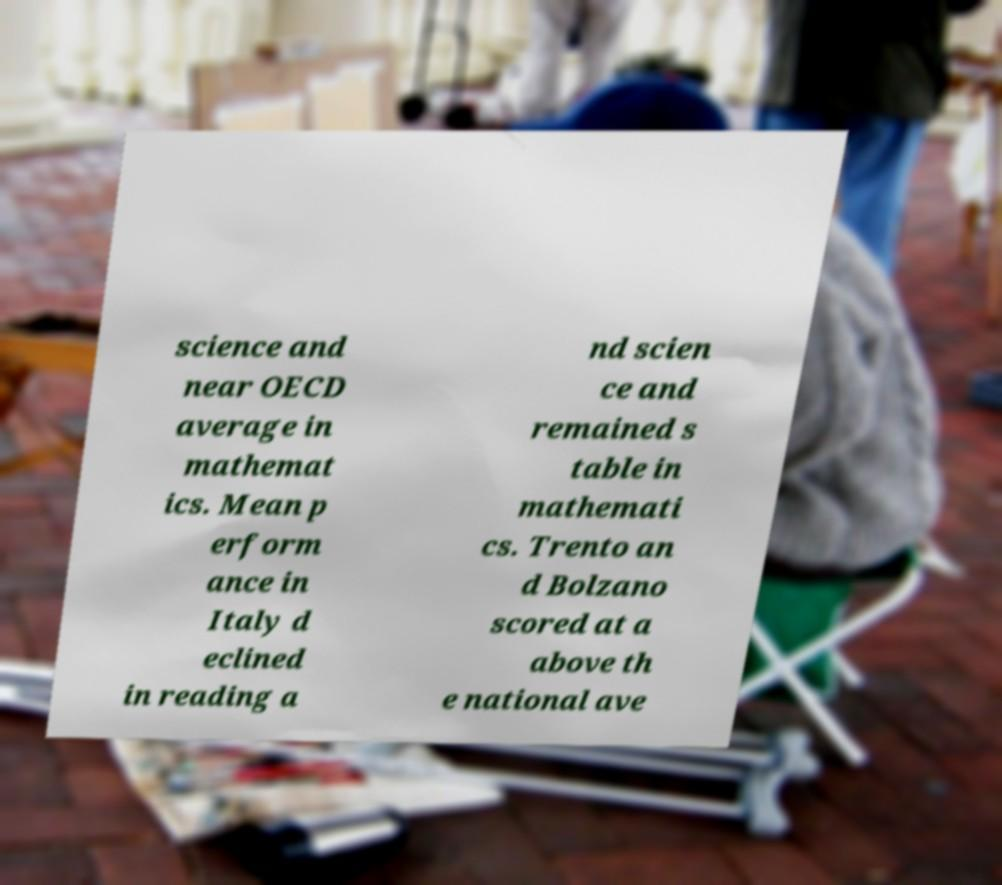Can you read and provide the text displayed in the image?This photo seems to have some interesting text. Can you extract and type it out for me? science and near OECD average in mathemat ics. Mean p erform ance in Italy d eclined in reading a nd scien ce and remained s table in mathemati cs. Trento an d Bolzano scored at a above th e national ave 